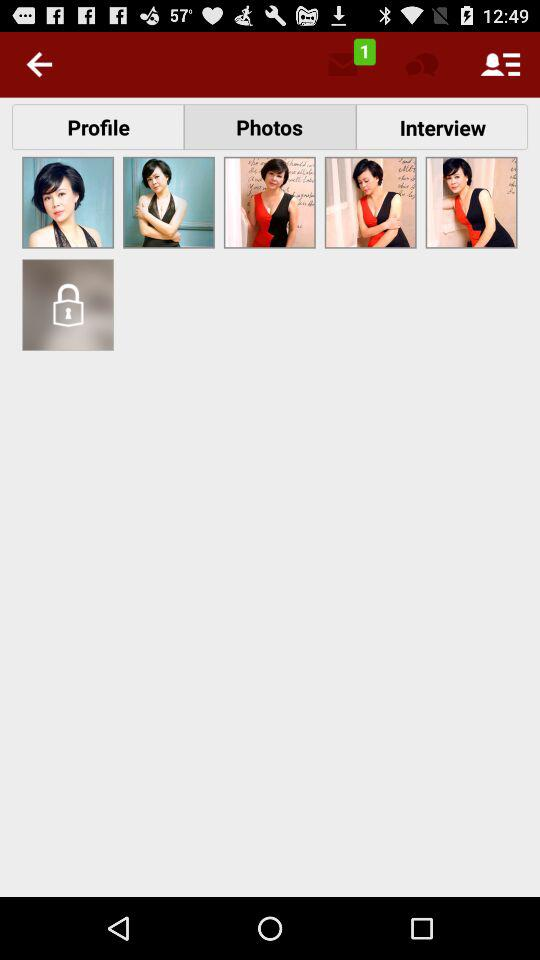Which tab is selected? The selected tab is "Photos". 